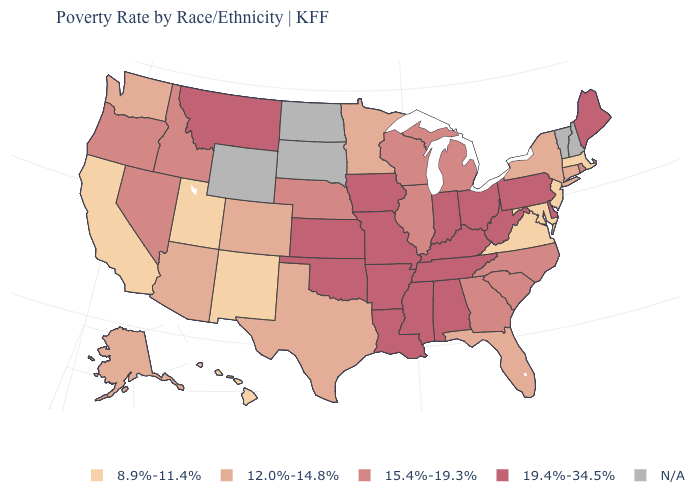Which states have the lowest value in the USA?
Short answer required. California, Hawaii, Maryland, Massachusetts, New Jersey, New Mexico, Utah, Virginia. Which states have the highest value in the USA?
Write a very short answer. Alabama, Arkansas, Delaware, Indiana, Iowa, Kansas, Kentucky, Louisiana, Maine, Mississippi, Missouri, Montana, Ohio, Oklahoma, Pennsylvania, Tennessee, West Virginia. What is the value of North Dakota?
Keep it brief. N/A. What is the value of Florida?
Write a very short answer. 12.0%-14.8%. Among the states that border Vermont , which have the lowest value?
Write a very short answer. Massachusetts. Which states have the lowest value in the South?
Give a very brief answer. Maryland, Virginia. Name the states that have a value in the range 19.4%-34.5%?
Quick response, please. Alabama, Arkansas, Delaware, Indiana, Iowa, Kansas, Kentucky, Louisiana, Maine, Mississippi, Missouri, Montana, Ohio, Oklahoma, Pennsylvania, Tennessee, West Virginia. What is the highest value in the Northeast ?
Short answer required. 19.4%-34.5%. Among the states that border Iowa , which have the highest value?
Quick response, please. Missouri. What is the lowest value in the West?
Be succinct. 8.9%-11.4%. Does Ohio have the lowest value in the MidWest?
Give a very brief answer. No. What is the value of Louisiana?
Answer briefly. 19.4%-34.5%. What is the value of Oklahoma?
Answer briefly. 19.4%-34.5%. Name the states that have a value in the range 15.4%-19.3%?
Keep it brief. Georgia, Idaho, Illinois, Michigan, Nebraska, Nevada, North Carolina, Oregon, Rhode Island, South Carolina, Wisconsin. Is the legend a continuous bar?
Give a very brief answer. No. 